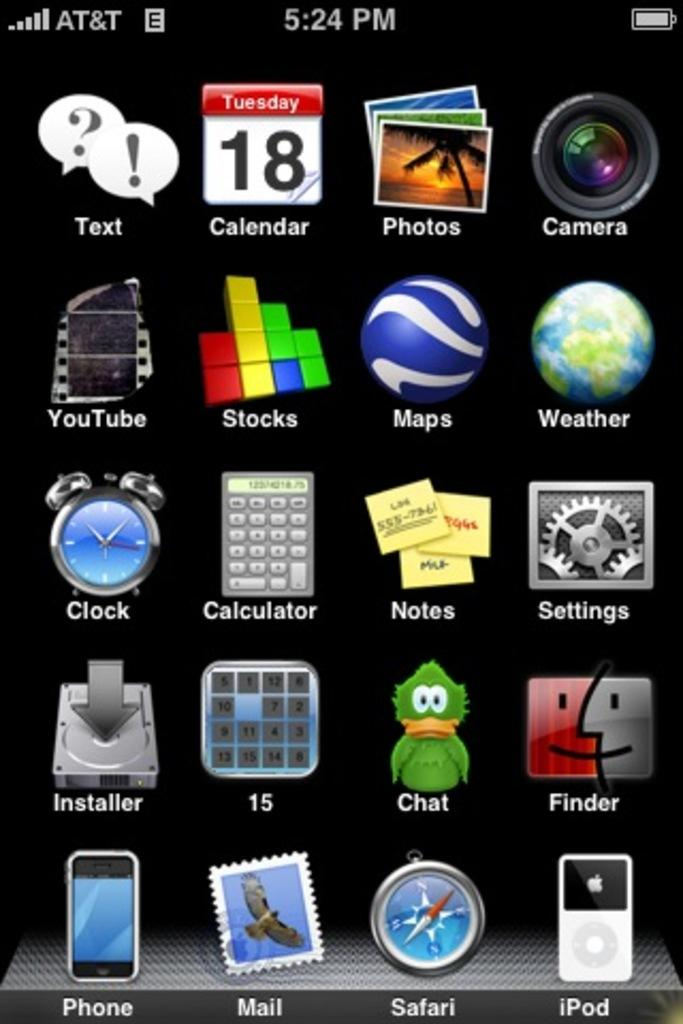<image>
Relay a brief, clear account of the picture shown. The home screen of an old iphone with apps like 15 and Chat. 